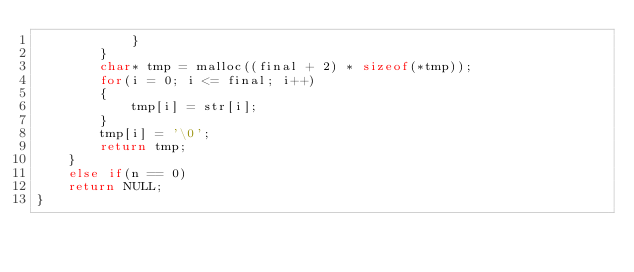<code> <loc_0><loc_0><loc_500><loc_500><_C_>			}
		}
		char* tmp = malloc((final + 2) * sizeof(*tmp));
		for(i = 0; i <= final; i++)
		{
			tmp[i] = str[i];
		}
		tmp[i] = '\0';
		return tmp;
	}
	else if(n == 0)
	return NULL;
}
</code> 